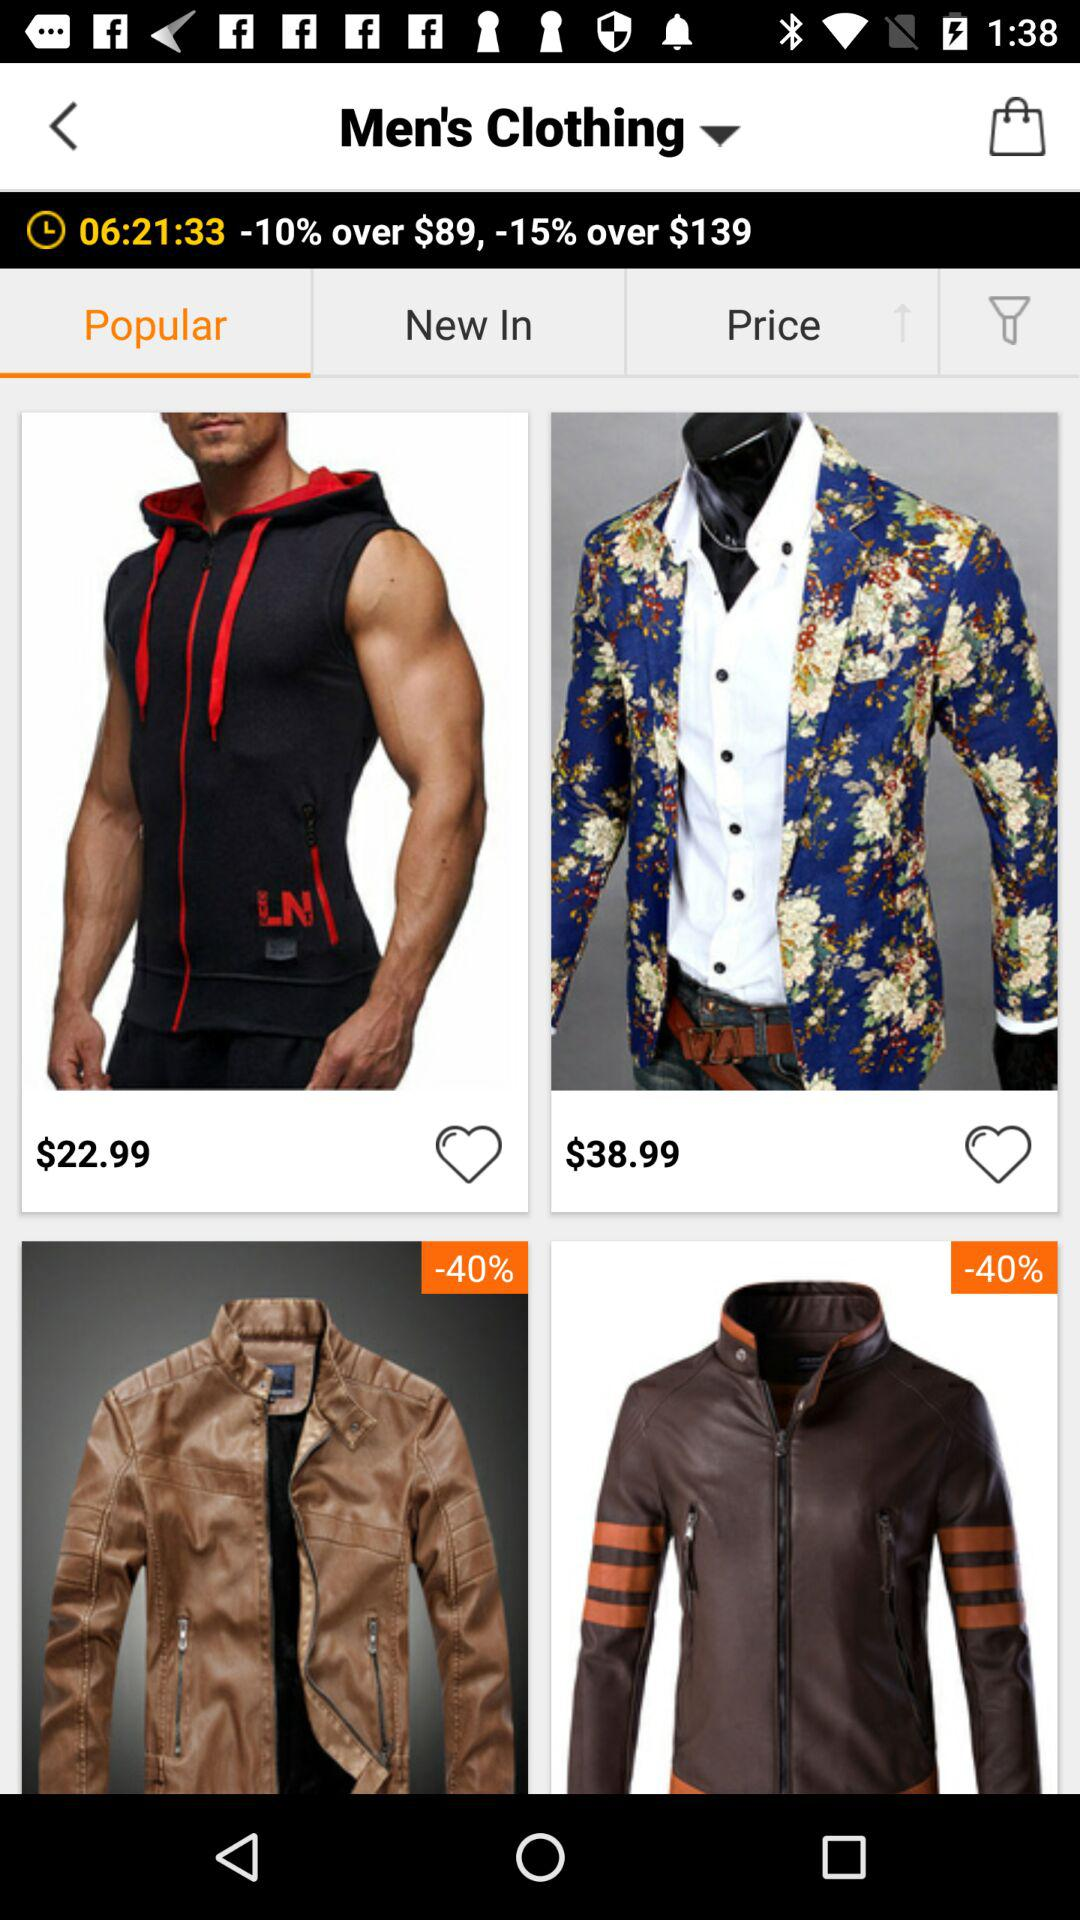What is the price of coat?
When the provided information is insufficient, respond with <no answer>. <no answer> 